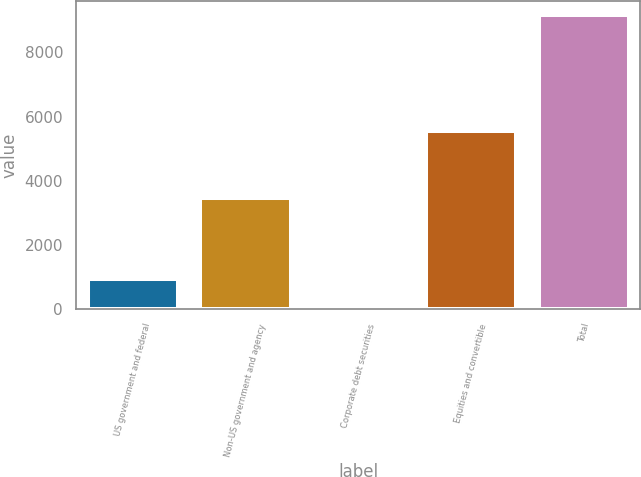Convert chart to OTSL. <chart><loc_0><loc_0><loc_500><loc_500><bar_chart><fcel>US government and federal<fcel>Non-US government and agency<fcel>Corporate debt securities<fcel>Equities and convertible<fcel>Total<nl><fcel>938.4<fcel>3463<fcel>26<fcel>5538<fcel>9150<nl></chart> 